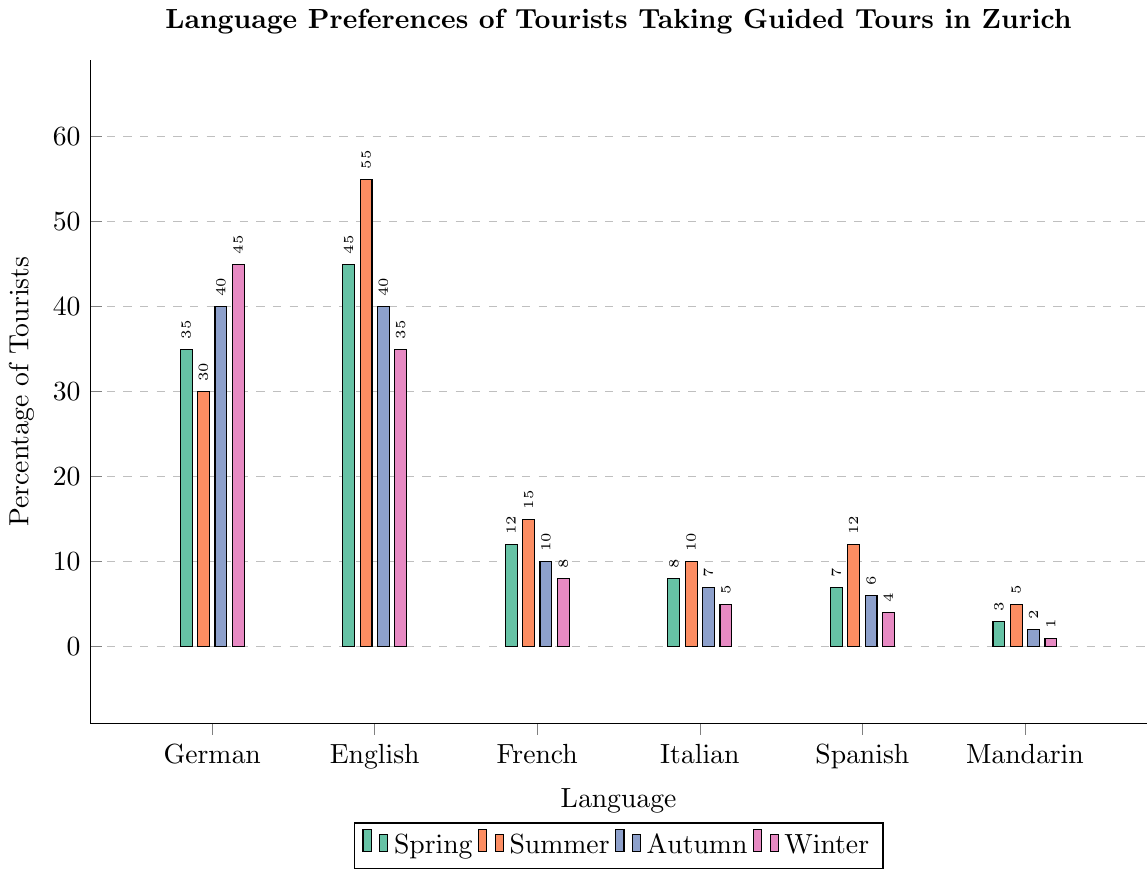Which language is preferred by the most tourists in summer? We look at the bar chart for summer and identify the language with the highest bar. In this case, it's English with 55%.
Answer: English Which language sees the most significant drop in preference from summer to winter? We compare the percentage values for each language in summer and winter and find the most significant drop. English drops from 55% to 35%, a difference of 20%.
Answer: English What is the average percentage of tourists preferring Italian across all seasons? Add the percentages for Italian across the four seasons (8+10+7+5) and divide by 4. The sum is 30, so 30 / 4 = 7.5%.
Answer: 7.5% Is there any season where German is not the most preferred language? We need to check if German has the highest bar in each season. Summer is the only season where English (55%) is more preferred than German (30%).
Answer: Yes, summer How many more tourists prefer Mandarin in summer compared to winter? We subtract the winter value for Mandarin (1%) from the summer value (5%). 5 - 1 = 4%.
Answer: 4% Which season sees the highest preference for Spanish? By comparing the bars for Spanish in each season, we see that summer has the highest preference at 12%.
Answer: Summer In which season is the preference for French lowest? We check the bar values for French in each season. Winter has the lowest preference at 8%.
Answer: Winter What is the total preference percentage for German and English combined in autumn? Add the percentages for German (40%) and English (40%) in autumn, resulting in 40 + 40 = 80%.
Answer: 80% Which season has the smallest variation in language preferences? We analyze the bar heights within each season to see the differences in percentage values. Autumn seems to have the smallest variation since most bars are close in height.
Answer: Autumn Is the preference for English always higher than French across all seasons? We compare English and French bars in each season. In all cases, the bar for English is higher than the bar for French.
Answer: Yes 